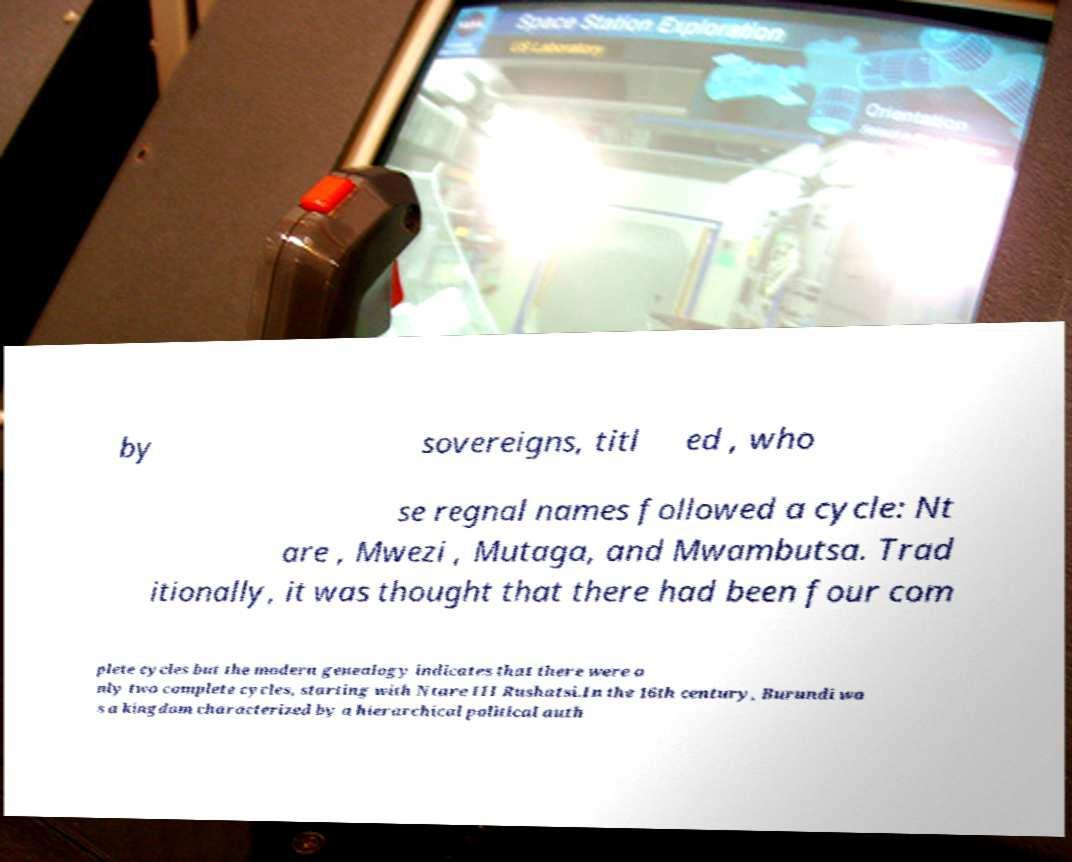What messages or text are displayed in this image? I need them in a readable, typed format. by sovereigns, titl ed , who se regnal names followed a cycle: Nt are , Mwezi , Mutaga, and Mwambutsa. Trad itionally, it was thought that there had been four com plete cycles but the modern genealogy indicates that there were o nly two complete cycles, starting with Ntare III Rushatsi.In the 16th century, Burundi wa s a kingdom characterized by a hierarchical political auth 